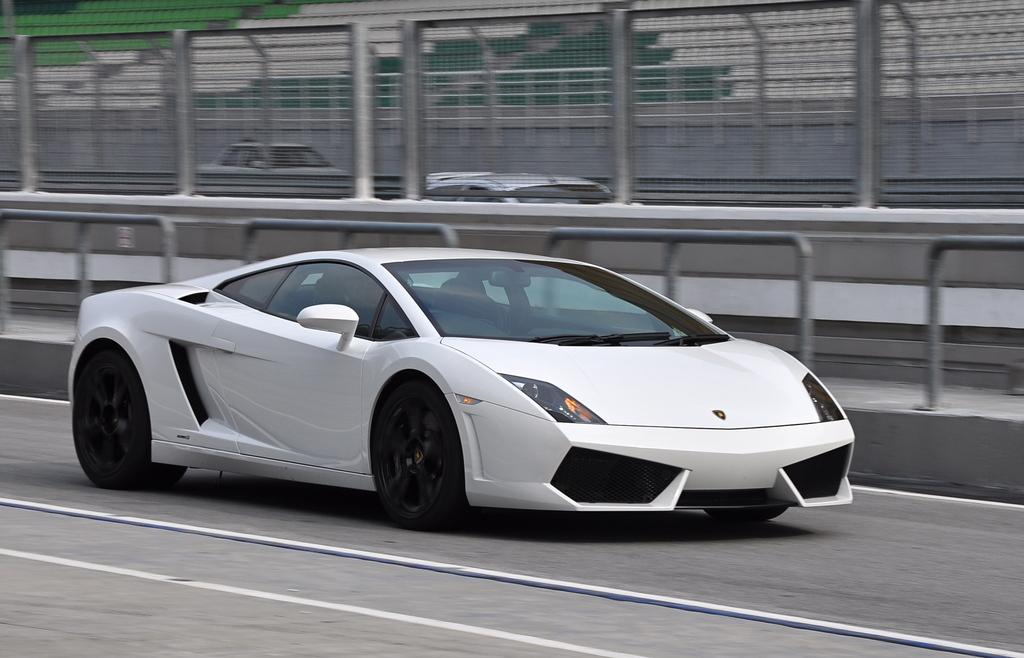What is the main subject of the image? There is a car on the road in the image. What can be seen in the background of the image? There are barricades and a fence in the background of the image. How many vehicles are visible in the background? There are two vehicles in the background of the image. Can you tell me how many astronauts are swimming in space in the image? There are no astronauts or swimming in space depicted in the image; it features a car on the road with barricades and a fence in the background. 